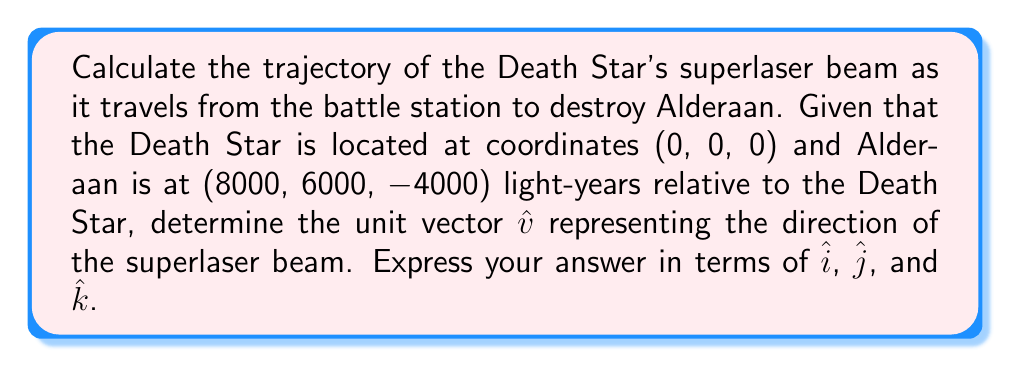Help me with this question. To calculate the trajectory of the Death Star's superlaser beam, we need to follow these steps:

1) First, let's identify the vector from the Death Star to Alderaan. This vector represents the displacement between the two points:

   $$\vec{r} = (8000, 6000, -4000)$$

2) To find the unit vector in this direction, we need to normalize this vector. The formula for a unit vector is:

   $$\hat{v} = \frac{\vec{r}}{|\vec{r}|}$$

3) To calculate $|\vec{r}|$, we use the magnitude formula:

   $$|\vec{r}| = \sqrt{x^2 + y^2 + z^2}$$

4) Substituting our values:

   $$|\vec{r}| = \sqrt{8000^2 + 6000^2 + (-4000)^2}$$
   $$= \sqrt{64,000,000 + 36,000,000 + 16,000,000}$$
   $$= \sqrt{116,000,000}$$
   $$= 10,770.33 \text{ light-years}$$

5) Now we can calculate the unit vector:

   $$\hat{v} = \frac{(8000, 6000, -4000)}{10,770.33}$$

6) Simplifying:

   $$\hat{v} = (0.7428\hat{i} + 0.5571\hat{j} - 0.3714\hat{k})$$

This unit vector represents the direction of the Death Star's superlaser beam as it travels towards Alderaan.
Answer: $\hat{v} = 0.7428\hat{i} + 0.5571\hat{j} - 0.3714\hat{k}$ 